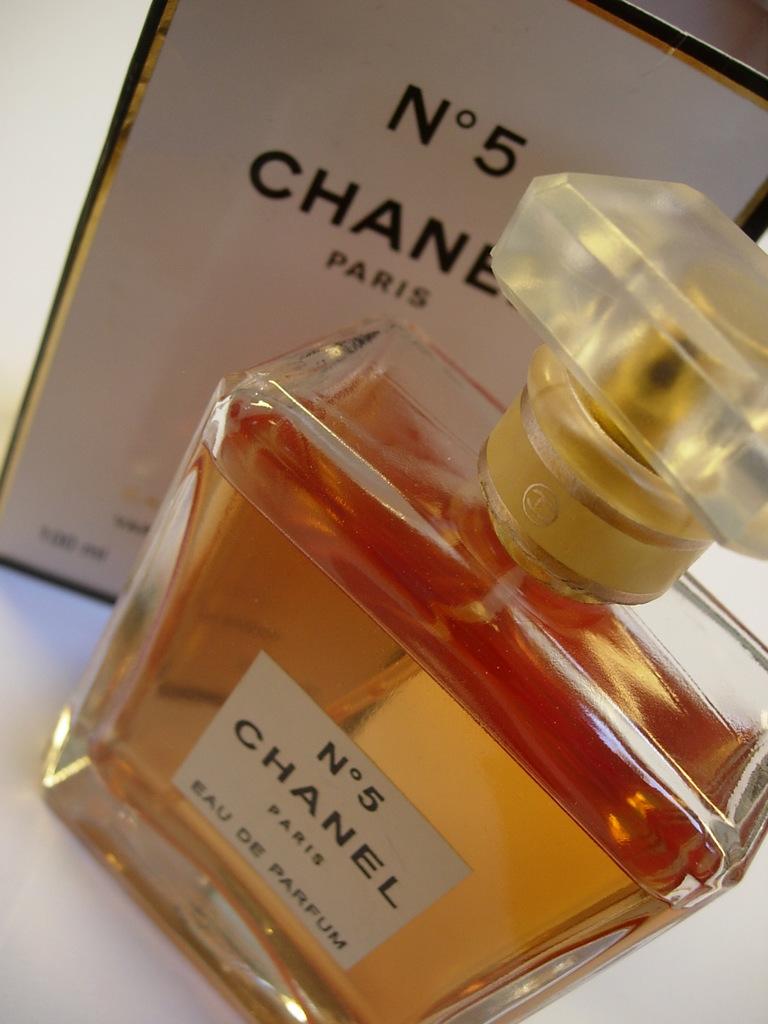What is the name of the perfume?
Your answer should be compact. Chanel. What city is the perfume from?
Your answer should be very brief. Paris. 